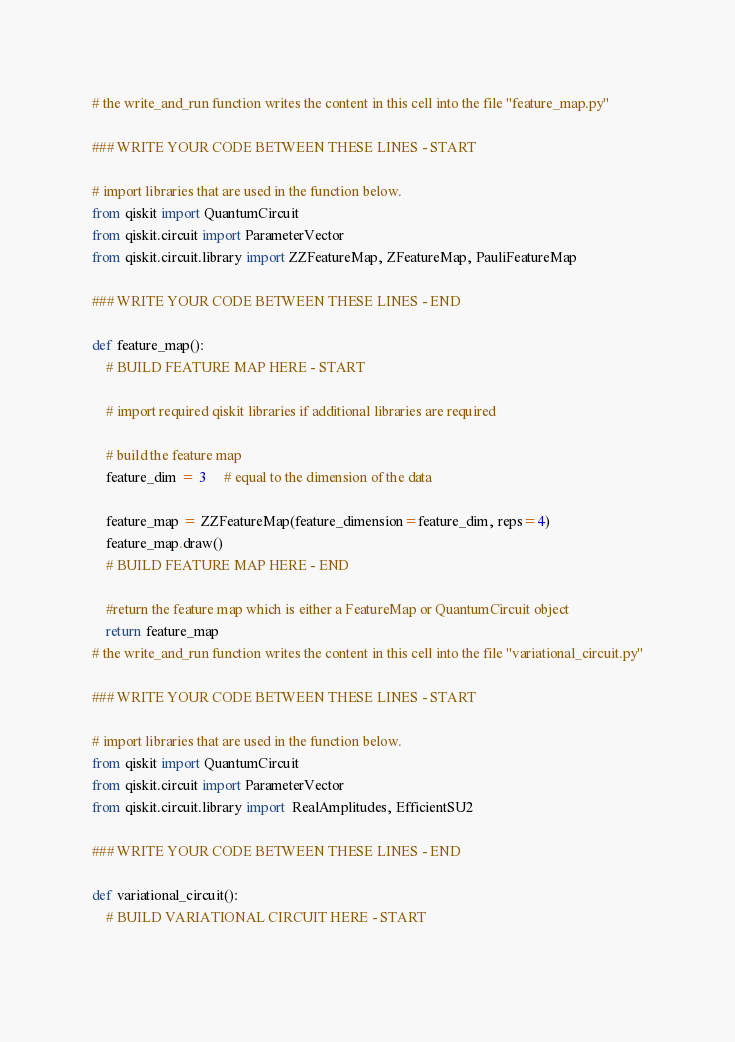<code> <loc_0><loc_0><loc_500><loc_500><_Python_># the write_and_run function writes the content in this cell into the file "feature_map.py"

### WRITE YOUR CODE BETWEEN THESE LINES - START
    
# import libraries that are used in the function below.
from qiskit import QuantumCircuit
from qiskit.circuit import ParameterVector
from qiskit.circuit.library import ZZFeatureMap, ZFeatureMap, PauliFeatureMap
    
### WRITE YOUR CODE BETWEEN THESE LINES - END

def feature_map(): 
    # BUILD FEATURE MAP HERE - START
    
    # import required qiskit libraries if additional libraries are required
    
    # build the feature map
    feature_dim = 3     # equal to the dimension of the data

    feature_map = ZZFeatureMap(feature_dimension=feature_dim, reps=4)
    feature_map.draw()
    # BUILD FEATURE MAP HERE - END
    
    #return the feature map which is either a FeatureMap or QuantumCircuit object
    return feature_map
# the write_and_run function writes the content in this cell into the file "variational_circuit.py"

### WRITE YOUR CODE BETWEEN THESE LINES - START
    
# import libraries that are used in the function below.
from qiskit import QuantumCircuit
from qiskit.circuit import ParameterVector
from qiskit.circuit.library import  RealAmplitudes, EfficientSU2
    
### WRITE YOUR CODE BETWEEN THESE LINES - END

def variational_circuit():
    # BUILD VARIATIONAL CIRCUIT HERE - START
    </code> 